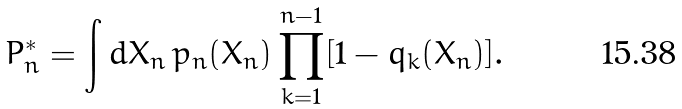Convert formula to latex. <formula><loc_0><loc_0><loc_500><loc_500>P _ { n } ^ { \ast } = \int d X _ { n } \, p _ { n } ( X _ { n } ) \prod _ { k = 1 } ^ { n - 1 } [ 1 - q _ { k } ( X _ { n } ) ] .</formula> 